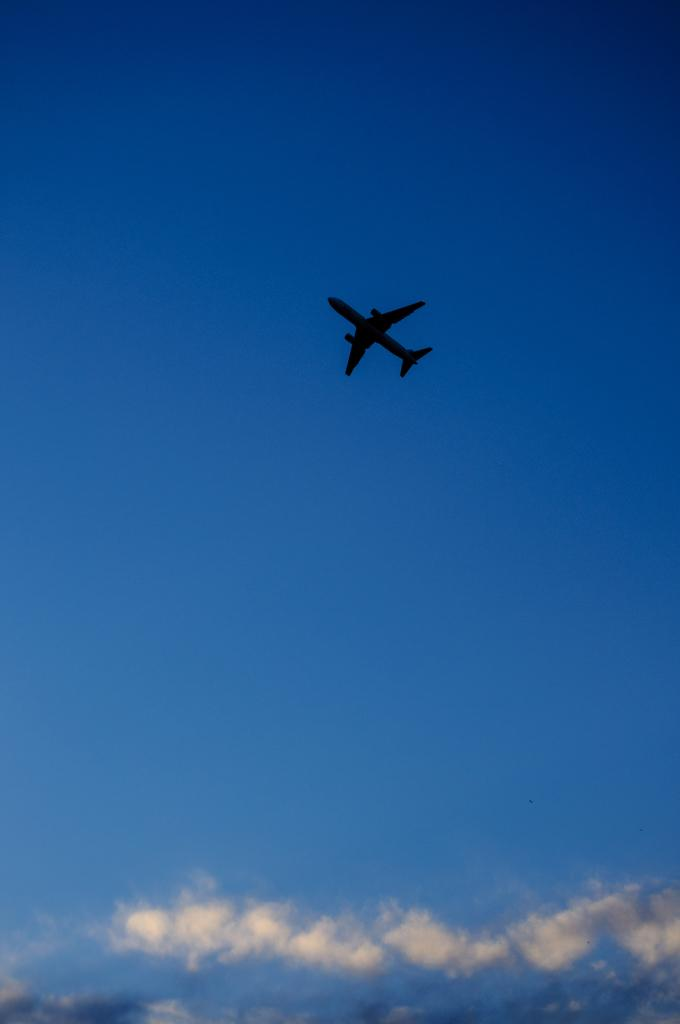What is happening in the sky in the image? There is a flight in the air in the image. What else can be seen in the sky besides the flight? The sky is visible in the image, and clouds are present. Can you see any arguments happening in the harbor in the image? There is no harbor present in the image, so it is not possible to see any arguments happening there. 